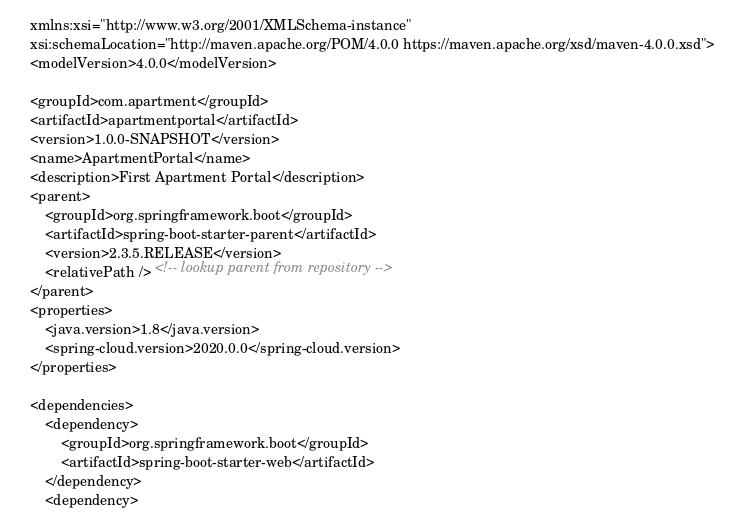Convert code to text. <code><loc_0><loc_0><loc_500><loc_500><_XML_>	xmlns:xsi="http://www.w3.org/2001/XMLSchema-instance"
	xsi:schemaLocation="http://maven.apache.org/POM/4.0.0 https://maven.apache.org/xsd/maven-4.0.0.xsd">
	<modelVersion>4.0.0</modelVersion>

	<groupId>com.apartment</groupId>
	<artifactId>apartmentportal</artifactId>
	<version>1.0.0-SNAPSHOT</version>
	<name>ApartmentPortal</name>
	<description>First Apartment Portal</description>
	<parent>
		<groupId>org.springframework.boot</groupId>
		<artifactId>spring-boot-starter-parent</artifactId>
		<version>2.3.5.RELEASE</version>
		<relativePath /> <!-- lookup parent from repository -->
	</parent>
	<properties>
		<java.version>1.8</java.version>
		<spring-cloud.version>2020.0.0</spring-cloud.version>
	</properties>

	<dependencies>
		<dependency>
			<groupId>org.springframework.boot</groupId>
			<artifactId>spring-boot-starter-web</artifactId>
		</dependency>
		<dependency></code> 